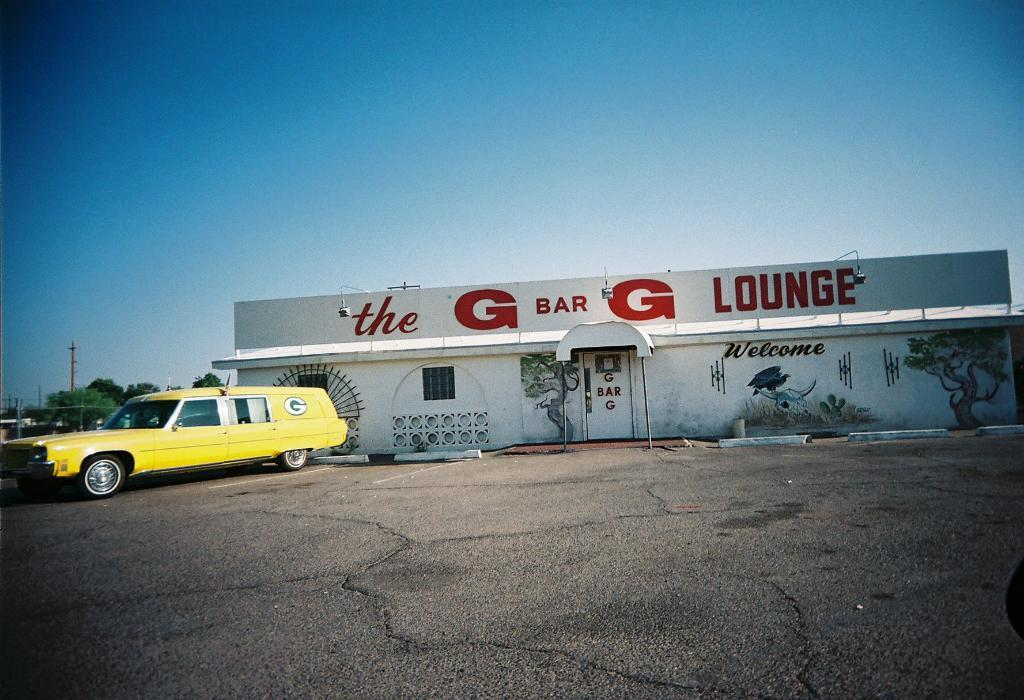What is located in the foreground of the image? There is a road in the foreground of the image. What can be seen in the middle of the image? There is a vehicle and a building in the middle of the image. What type of vegetation is visible in the background of the image? There are trees in the background of the image. What else can be seen in the background of the image? There are poles and the sky visible in the background of the image. Are there any toys being used in a protest against pollution in the image? There is no indication of toys, protest, or pollution in the image. The image primarily features a road, a vehicle, a building, trees, poles, and the sky. 